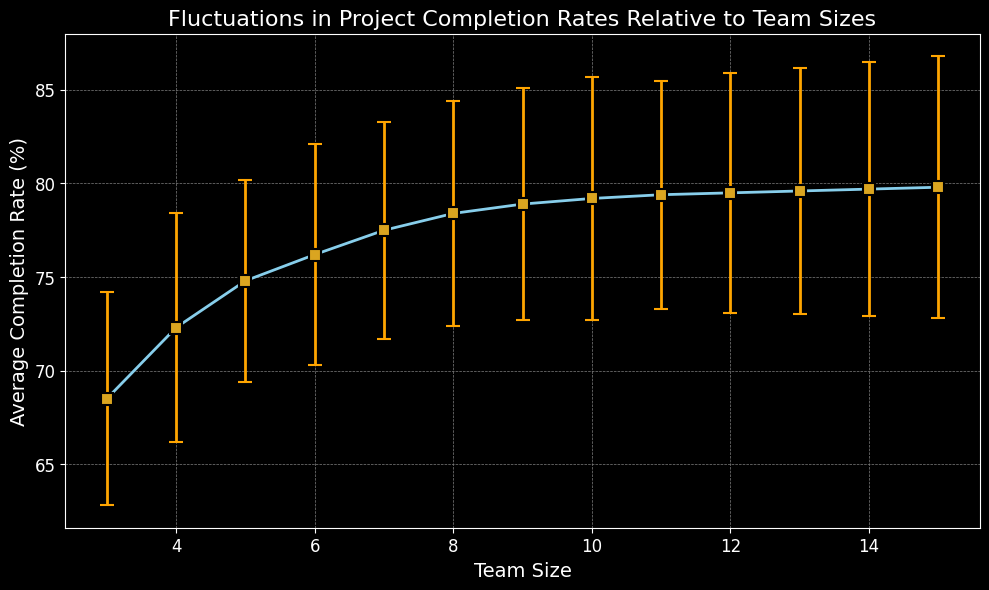What is the approximate average completion rate for a team size of 10? The graph shows the average completion rate on the y-axis and team size on the x-axis. For a team size of 10, observe the corresponding point on the y-axis.
Answer: 79.2% Which team size has the highest average completion rate? By comparing all the plotted data points on the graph, locate the point that is farthest up on the y-axis.
Answer: Team size 15 Which team size has the lowest standard deviation in completion rate? The standard deviation is depicted by the length of the error bars extending above and below the points. The team size with the shortest error bars has the lowest standard deviation.
Answer: Team size 5 How does the average completion rate change from a team size of 3 to a team size of 15? Note the average completion rates for team sizes 3 and 15 from the y-axis and calculate the difference between these rates.
Answer: Increases from 68.5% to 79.8% Is there a visible trend in the average completion rate as team size increases? By observing the slope and general direction of the plotted points connected by the line, determine if there is an upward, downward, or no clear trend.
Answer: Upward trend What is the difference in average completion rates between team sizes 6 and 12? Refer to the average completion rates for team sizes 6 and 12 on the y-axis and subtract the smaller rate from the larger one.
Answer: 3.3% Does the plot show that smaller team sizes have more fluctuations in completion rates compared to larger team sizes? Compare the lengths of the error bars for smaller team sizes (3, 4, 5) and larger team sizes (13, 14, 15) to see if the former have generally longer error bars.
Answer: Yes What is the range of average completion rates shown in the chart? Identify the minimum and maximum average completion rates from the y-axis and compute the range by subtracting the minimum value from the maximum value.
Answer: 11.3% How does the error bar for a team size of 11 compare with that for a team size of 7? Visually compare the lengths of the error bars for team sizes 11 and 7 to determine which is longer or if they are similar in length.
Answer: Similar in length 